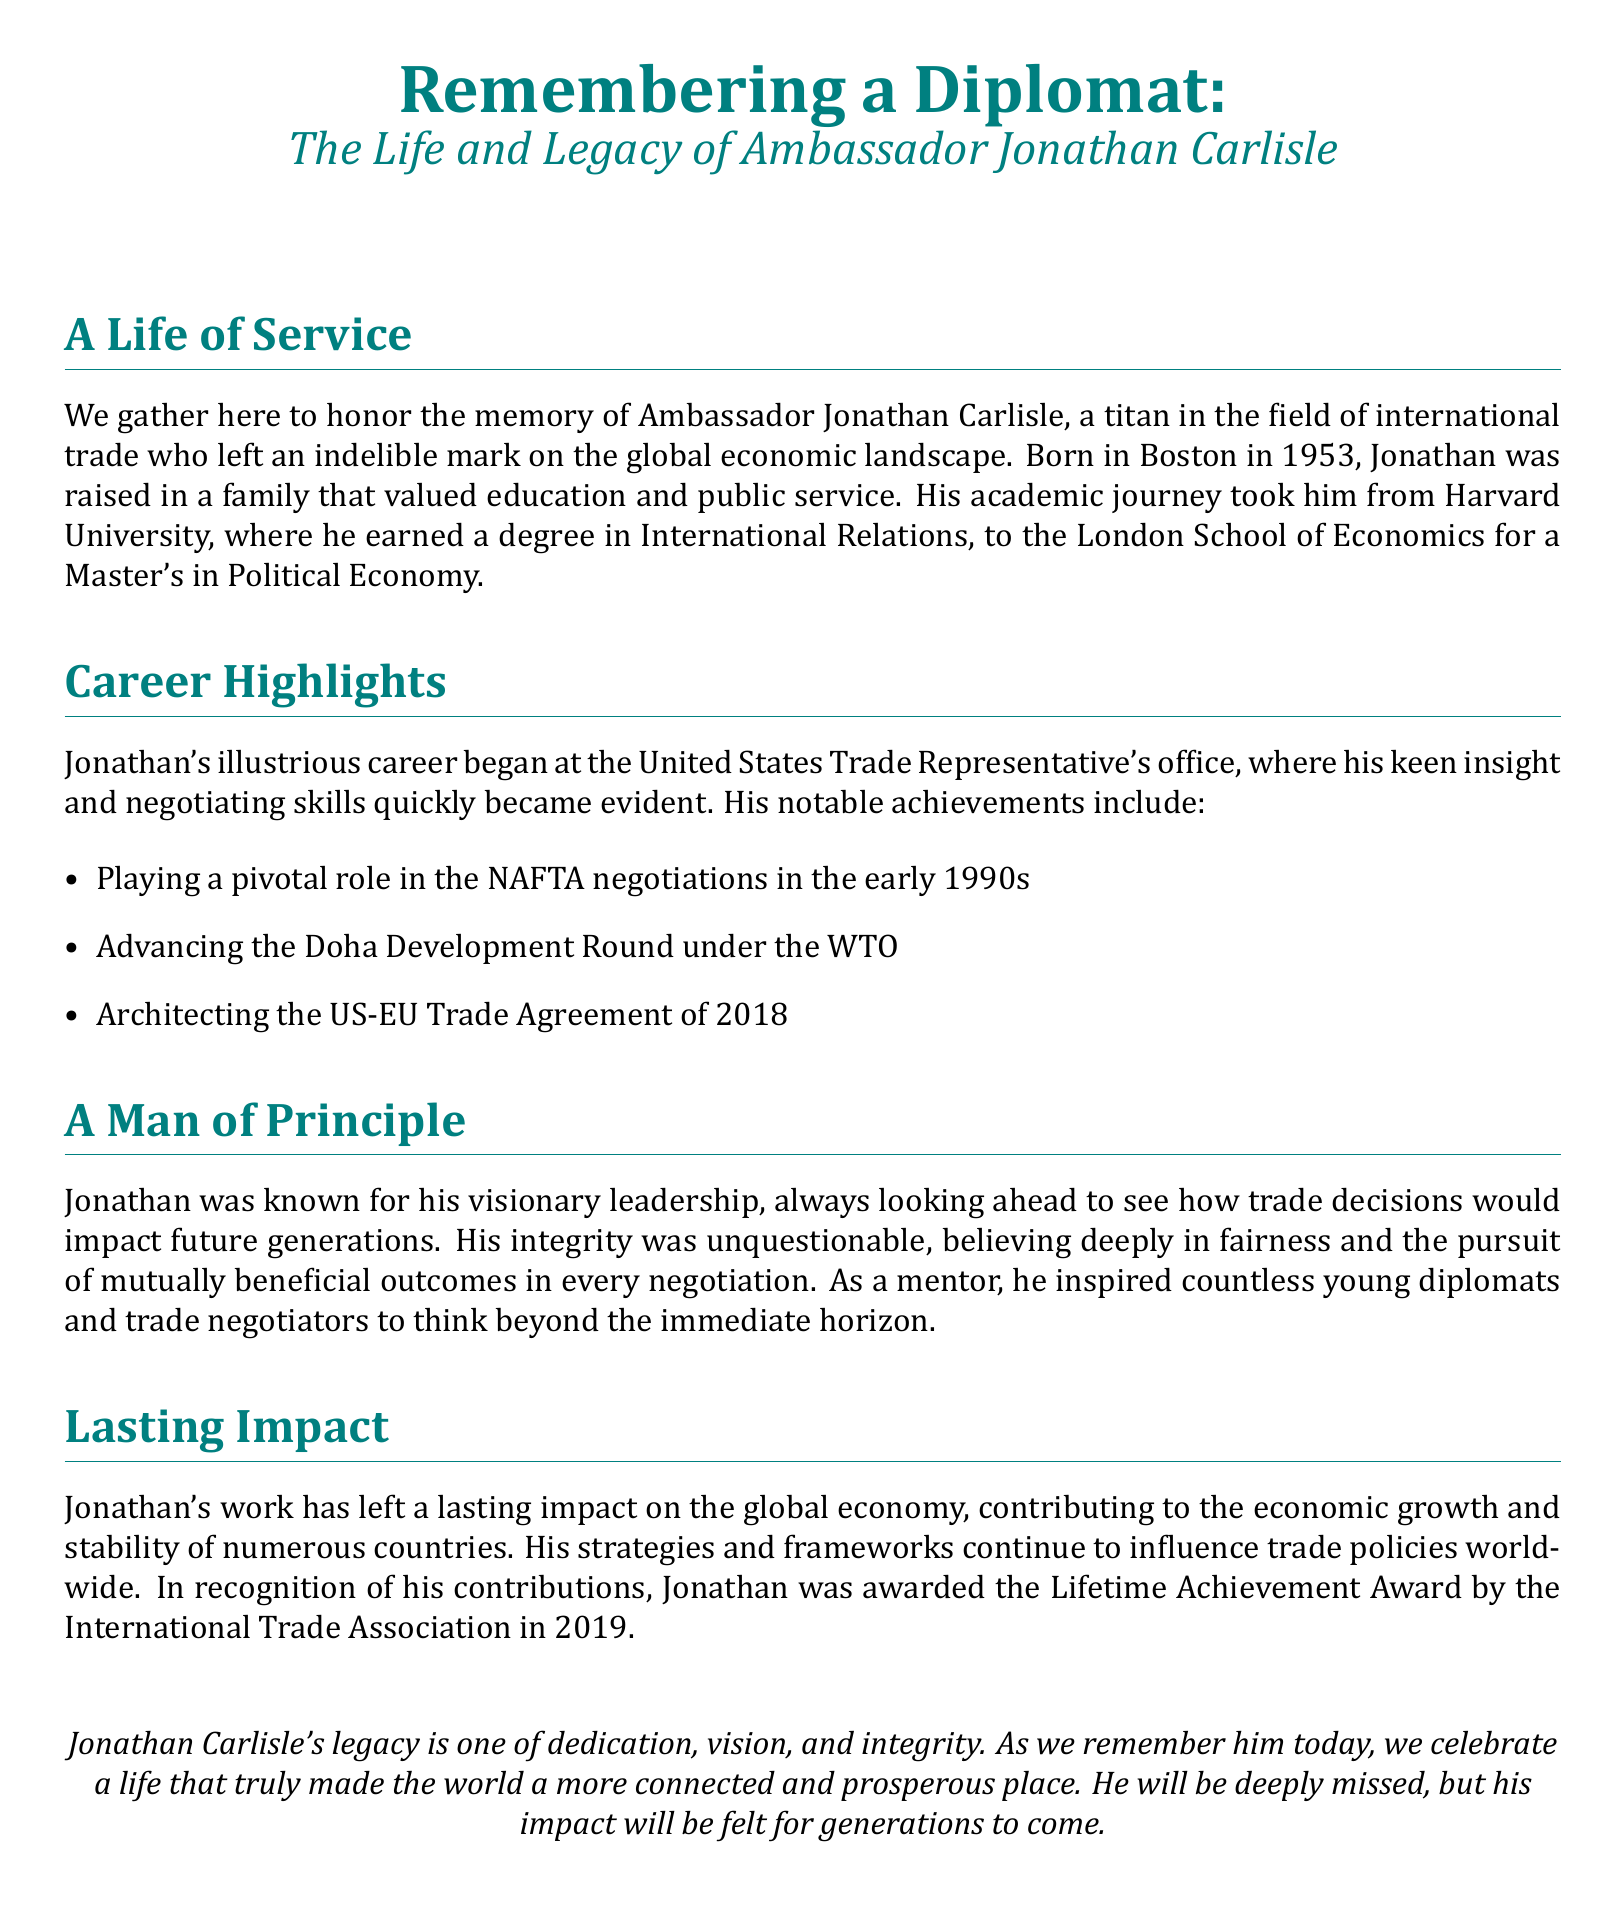What year was Jonathan Carlisle born? The document states that Jonathan was born in Boston in 1953.
Answer: 1953 What significant trade agreement did Jonathan play a role in negotiating in the early 1990s? The document mentions his pivotal role in the NAFTA negotiations.
Answer: NAFTA What award did Jonathan receive in 2019? According to the document, he was awarded the Lifetime Achievement Award by the International Trade Association.
Answer: Lifetime Achievement Award Which university did Jonathan attend for his Master's degree? The document specifies that he earned a Master's in Political Economy from the London School of Economics.
Answer: London School of Economics What principle was Jonathan known for in trade negotiations? The document highlights his belief in fairness and mutually beneficial outcomes.
Answer: Fairness What role did Jonathan have in relation to the Doha Development Round? The document notes that he advanced the Doha Development Round under the WTO.
Answer: Advanced In what field did Jonathan contribute to global economic impact? The document emphasizes his contributions to international trade.
Answer: International trade What was a notable characteristic of Jonathan's leadership style? The document describes him as having visionary leadership, looking ahead to future impacts.
Answer: Visionary leadership 